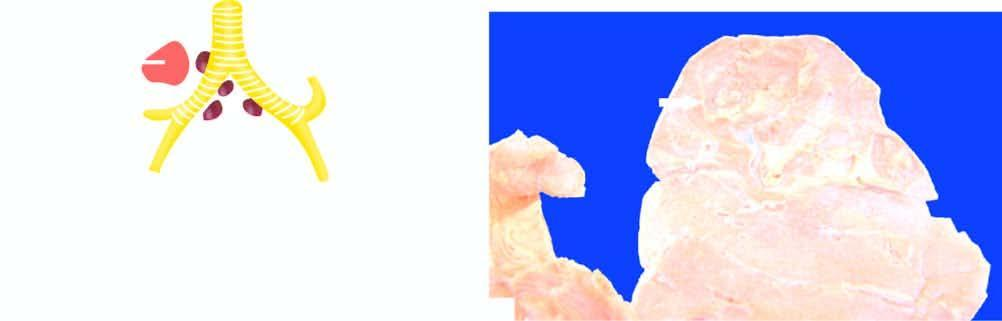what is there of lung parenchyma surrounding the cavity?
Answer the question using a single word or phrase. Consolidation 